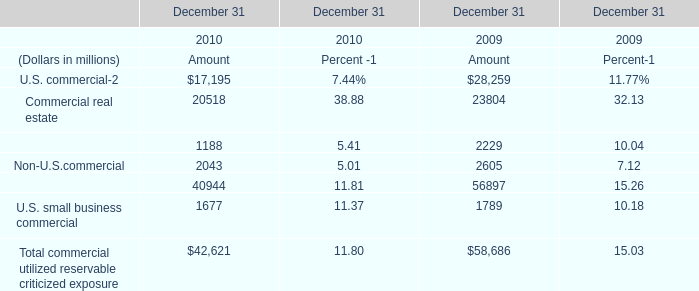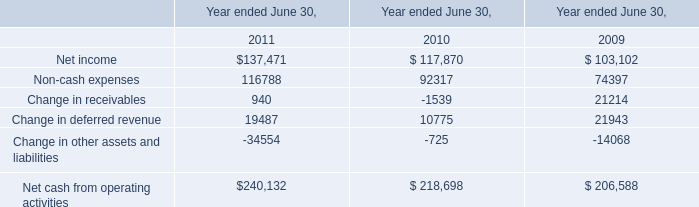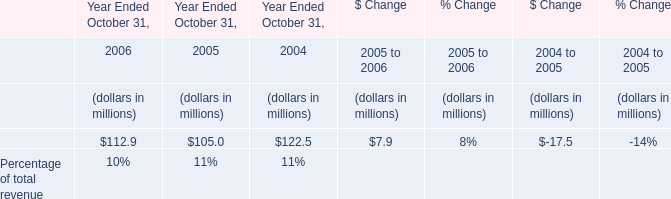What's the average of the Commercial real estate and Commercial lease financing in the year where U.S. commercia is positive? (in million) 
Computations: ((23804 + 2229) / 2)
Answer: 13016.5. 